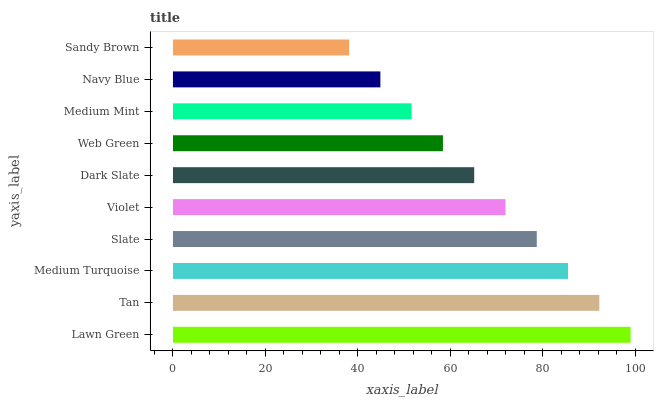Is Sandy Brown the minimum?
Answer yes or no. Yes. Is Lawn Green the maximum?
Answer yes or no. Yes. Is Tan the minimum?
Answer yes or no. No. Is Tan the maximum?
Answer yes or no. No. Is Lawn Green greater than Tan?
Answer yes or no. Yes. Is Tan less than Lawn Green?
Answer yes or no. Yes. Is Tan greater than Lawn Green?
Answer yes or no. No. Is Lawn Green less than Tan?
Answer yes or no. No. Is Violet the high median?
Answer yes or no. Yes. Is Dark Slate the low median?
Answer yes or no. Yes. Is Sandy Brown the high median?
Answer yes or no. No. Is Sandy Brown the low median?
Answer yes or no. No. 